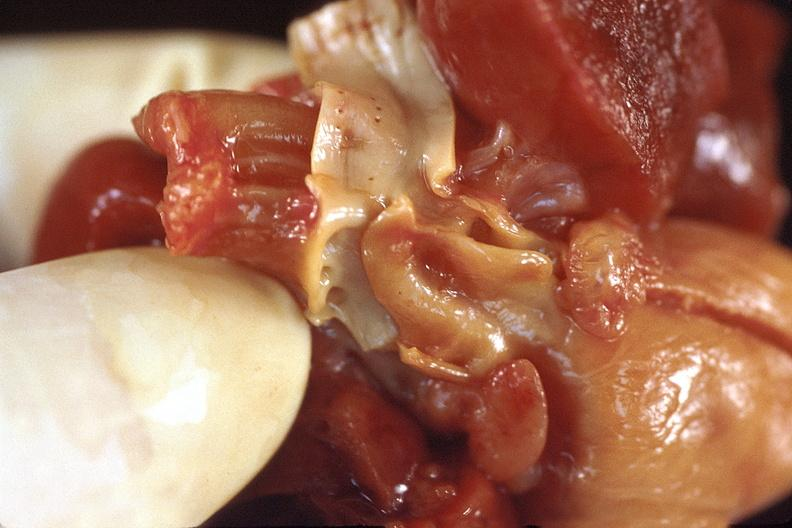what does this image show?
Answer the question using a single word or phrase. Heart 